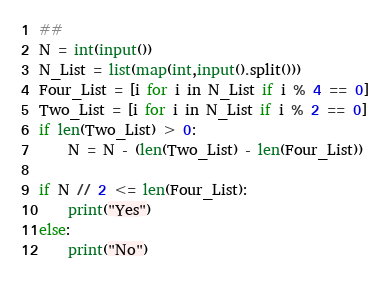Convert code to text. <code><loc_0><loc_0><loc_500><loc_500><_Python_>##
N = int(input())
N_List = list(map(int,input().split()))
Four_List = [i for i in N_List if i % 4 == 0]
Two_List = [i for i in N_List if i % 2 == 0]
if len(Two_List) > 0:
    N = N - (len(Two_List) - len(Four_List)) 

if N // 2 <= len(Four_List):
    print("Yes")
else:
    print("No")</code> 